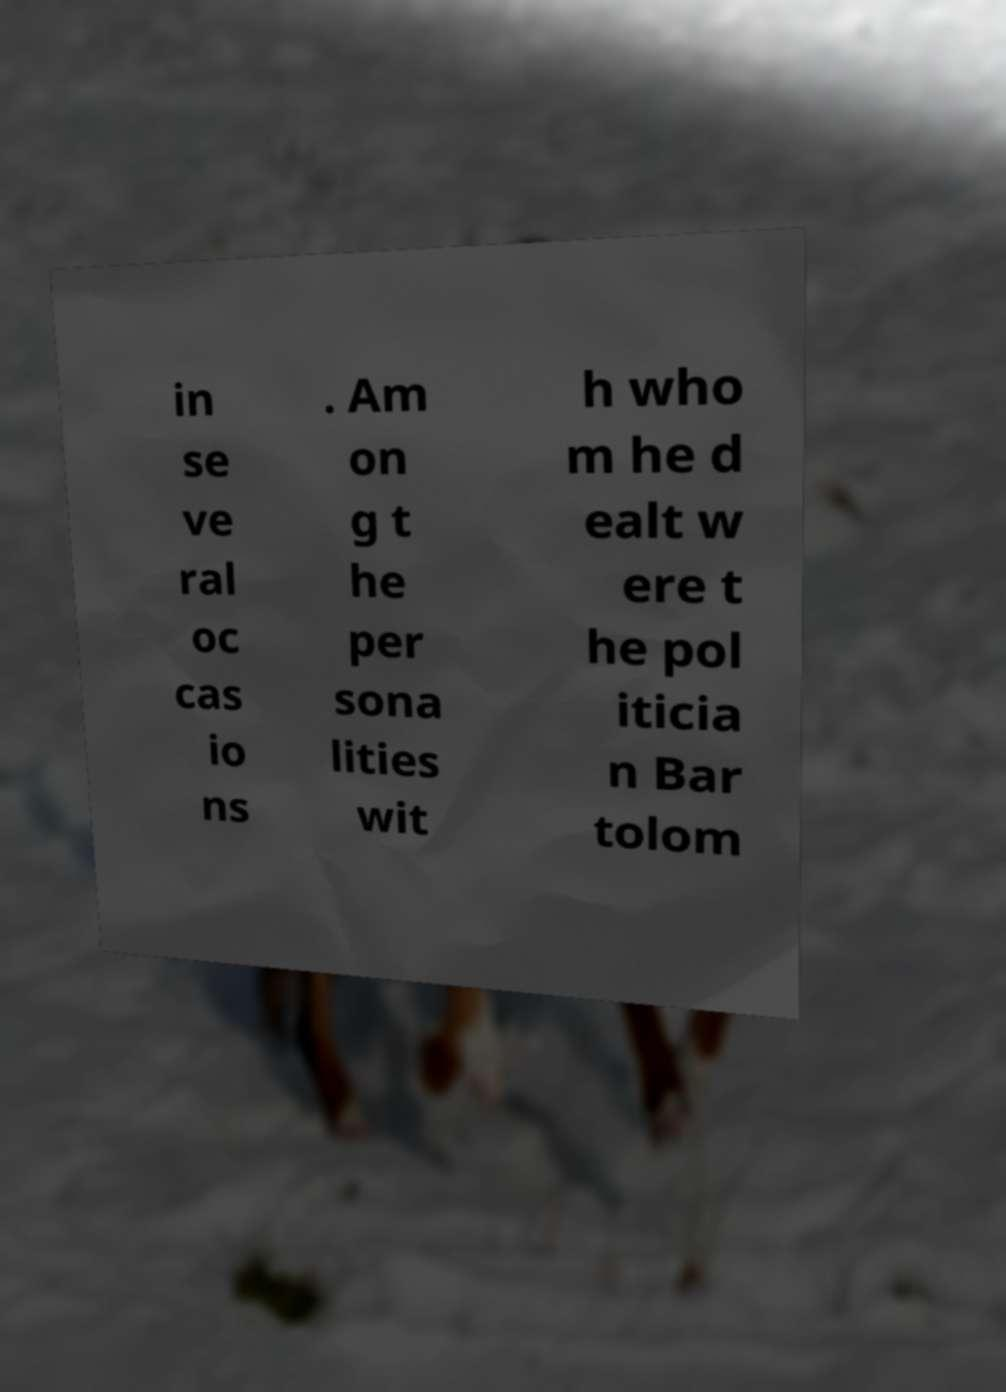What messages or text are displayed in this image? I need them in a readable, typed format. in se ve ral oc cas io ns . Am on g t he per sona lities wit h who m he d ealt w ere t he pol iticia n Bar tolom 